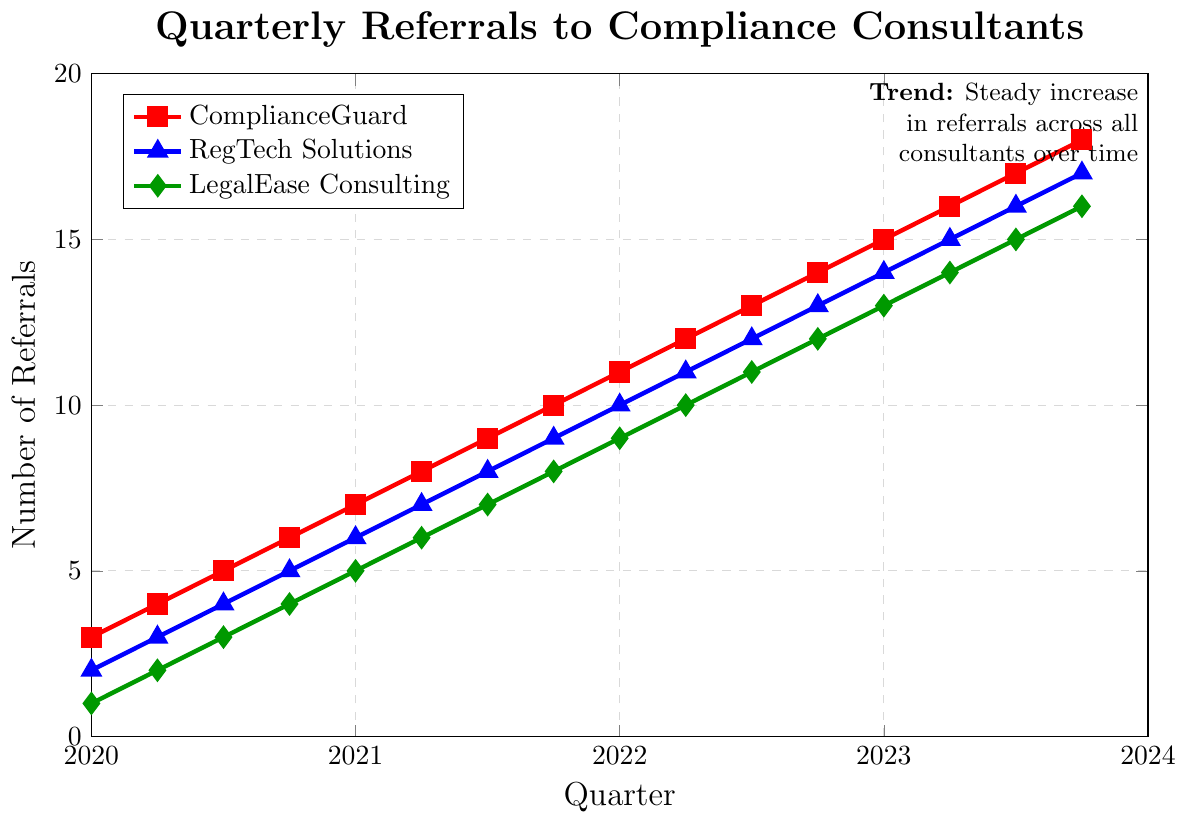What is the trend observed in referrals across all consultants over time? By observing the figure, we can see that the number of referrals for ComplianceGuard, RegTech Solutions, and LegalEase Consulting increases steadily from Q1 2020 to Q4 2023. This indicates a consistent upward trend for all consultants.
Answer: Steady increase Between ComplianceGuard and RegTech Solutions, which consultant had more referrals in Q2 2021? In Q2 2021, the figure shows that ComplianceGuard had 8 referrals, and RegTech Solutions had 7 referrals. Since 8 is greater than 7, ComplianceGuard had more referrals.
Answer: ComplianceGuard By how much did the referrals for LegalEase Consulting increase from Q1 2022 to Q4 2023? The number of referrals for LegalEase Consulting was 9 in Q1 2022 and increased to 16 by Q4 2023. The increase is calculated as 16 - 9 = 7.
Answer: 7 What is the difference in the number of referrals between ComplianceGuard and LegalEase Consulting in Q4 2022? In Q4 2022, ComplianceGuard had 14 referrals, and LegalEase Consulting had 12. The difference is calculated as 14 - 12 = 2.
Answer: 2 Which consultant had the least number of referrals in Q1 2020? In Q1 2020, the figure shows that ComplianceGuard had 3 referrals, RegTech Solutions had 2 referrals, and LegalEase Consulting had 1 referral. Since 1 is the smallest number, LegalEase Consulting had the least referrals.
Answer: LegalEase Consulting What is the total number of referrals for RegTech Solutions over 2020? The referrals for RegTech Solutions in 2020 are 2, 3, 4, and 5 for Q1, Q2, Q3, and Q4 respectively. Summing these values gives 2 + 3 + 4 + 5 = 14.
Answer: 14 How many more referrals did ComplianceGuard have in Q3 2023 compared to Q1 2020? ComplianceGuard had 3 referrals in Q1 2020 and 17 referrals in Q3 2023. The difference is calculated as 17 - 3 = 14.
Answer: 14 When did ComplianceGuard, RegTech Solutions, and LegalEase Consulting each hit double-digit referrals? ComplianceGuard hit double-digit referrals in Q1 2022, RegTech Solutions in Q2 2022, and LegalEase Consulting in Q3 2022.
Answer: Q1 2022, Q2 2022, Q3 2022 What is the average number of referrals for ComplianceGuard in 2021? ComplianceGuard had 7, 8, 9, and 10 referrals in Q1, Q2, Q3, and Q4 of 2021 respectively. The sum is 7+8+9+10 = 34. The average is 34/4 = 8.5.
Answer: 8.5 